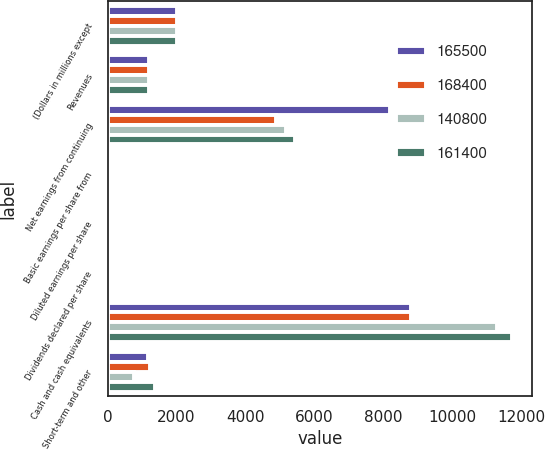Convert chart to OTSL. <chart><loc_0><loc_0><loc_500><loc_500><stacked_bar_chart><ecel><fcel>(Dollars in millions except<fcel>Revenues<fcel>Net earnings from continuing<fcel>Basic earnings per share from<fcel>Diluted earnings per share<fcel>Dividends declared per share<fcel>Cash and cash equivalents<fcel>Short-term and other<nl><fcel>165500<fcel>2017<fcel>1203.5<fcel>8197<fcel>13.6<fcel>13.43<fcel>5.97<fcel>8813<fcel>1179<nl><fcel>168400<fcel>2016<fcel>1203.5<fcel>4895<fcel>7.7<fcel>7.61<fcel>4.69<fcel>8801<fcel>1228<nl><fcel>140800<fcel>2015<fcel>1203.5<fcel>5176<fcel>7.52<fcel>7.44<fcel>3.82<fcel>11302<fcel>750<nl><fcel>161400<fcel>2014<fcel>1203.5<fcel>5446<fcel>7.47<fcel>7.38<fcel>3.1<fcel>11733<fcel>1359<nl></chart> 